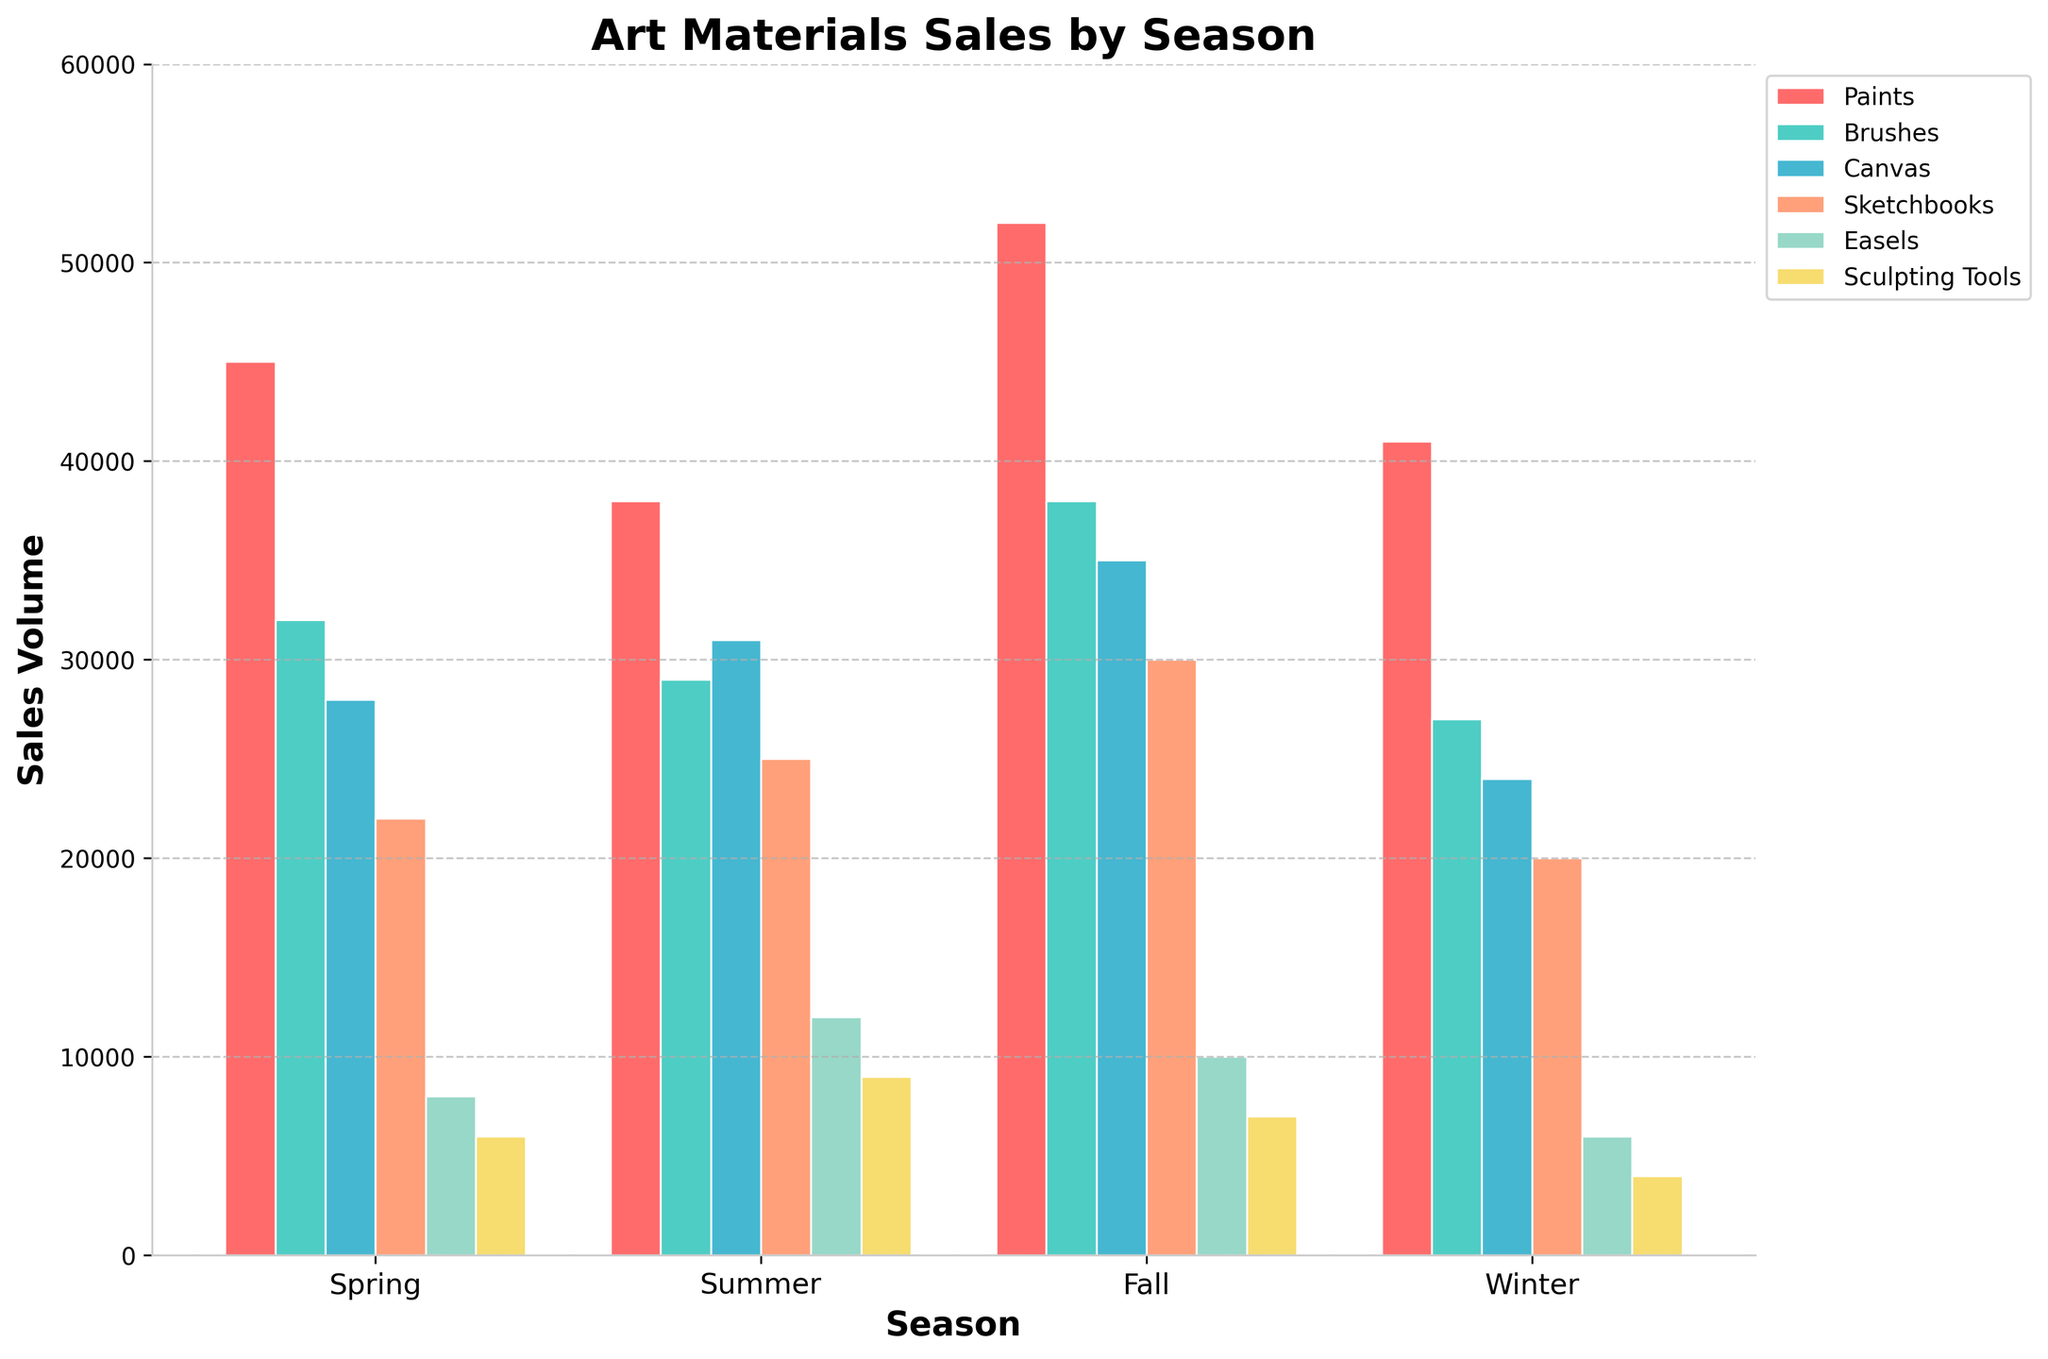What is the highest sales volume among all seasons for Paints? To find the highest sales volume for Paints, we check the values for each season: Spring (45000), Summer (38000), Fall (52000), Winter (41000). The highest value is 52000 in Fall.
Answer: 52000 Which category had the smallest sales volume in Spring? In Spring, the sales volumes are: Paints (45000), Brushes (32000), Canvas (28000), Sketchbooks (22000), Easels (8000), Sculpting Tools (6000). The smallest value is 6000 for Sculpting Tools.
Answer: Sculpting Tools Compare the sales volume for Easels in Summer and Fall. Which season had higher sales? Easels sales volume in Summer is 12000, and in Fall, it is 10000. Comparing these, Summer has the higher sales volume.
Answer: Summer By how much does the sales volume for Canvas in Fall exceed the sales volume in Winter? Canvas sales volume in Fall is 35000, and in Winter, it is 24000. The difference is calculated as 35000 - 24000 = 11000.
Answer: 11000 What is the total sales volume for Brushes across all seasons? The sales volumes for Brushes are Spring (32000), Summer (29000), Fall (38000), Winter (27000). Summing these: 32000 + 29000 + 38000 + 27000 = 126000.
Answer: 126000 Which season has the lowest total sales volume for all categories combined? Summing the sales volumes for each season: 
- Spring: 45000 + 32000 + 28000 + 22000 + 8000 + 6000 = 141000
- Summer: 38000 + 29000 + 31000 + 25000 + 12000 + 9000 = 144000
- Fall: 52000 + 38000 + 35000 + 30000 + 10000 + 7000 = 172000
- Winter: 41000 + 27000 + 24000 + 20000 + 6000 + 4000 = 122000
The lowest total is in Winter with 122000.
Answer: Winter What are the three art material categories with the highest sales volume in Summer? The sales volumes in Summer are Paints (38000), Brushes (29000), Canvas (31000), Sketchbooks (25000), Easels (12000), Sculpting Tools (9000). The three highest values are Paints (38000), Canvas (31000), and Brushes (29000).
Answer: Paints, Canvas, Brushes By how much does the total sales volume in Spring differ from that in Fall? The total sales volume in Spring is 141000, and in Fall, it is 172000. The difference is calculated as 172000 - 141000 = 31000.
Answer: 31000 